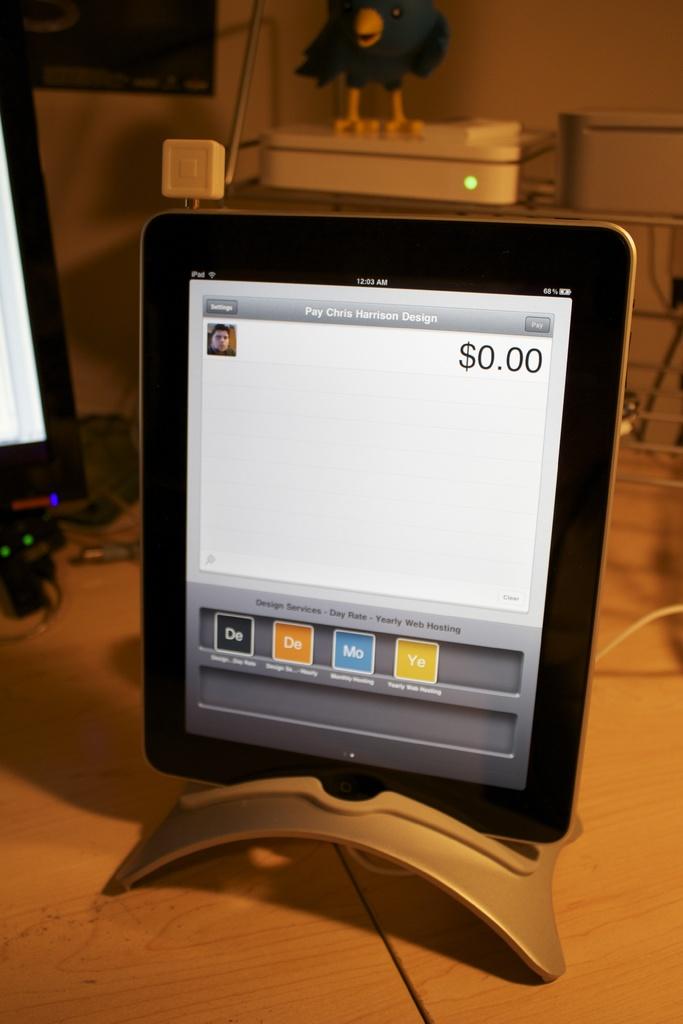Is there any money on the screen?
Your response must be concise. No. 